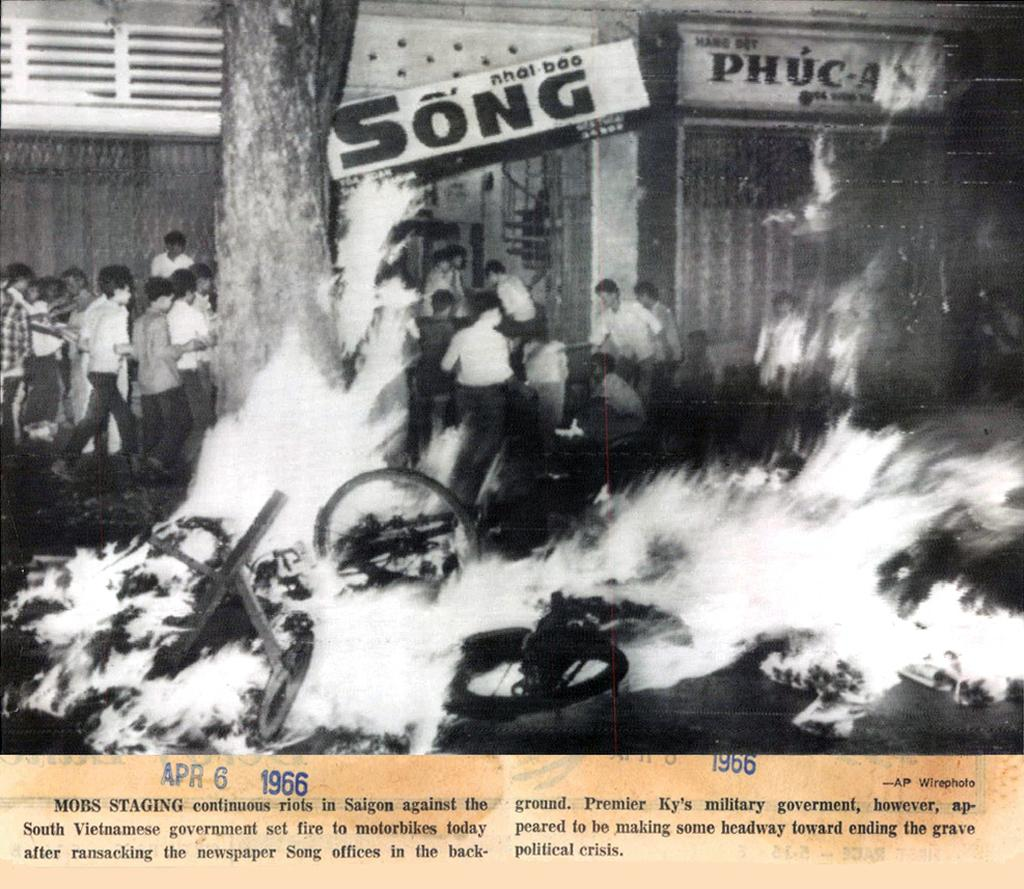What type of medium is the image a part of? The image is part of a poster. What can be found on the poster besides the image? There are texts on the poster. What is depicted in the image? In the image, there are persons, a tree, fire, a banner, a hoarding, and a building. What type of pump is being used by the family in the image? There is no family or pump present in the image. Can you tell me what type of berry is being picked by the persons in the image? There is no berry-picking activity depicted in the image; the persons are not interacting with any plants or fruits. 